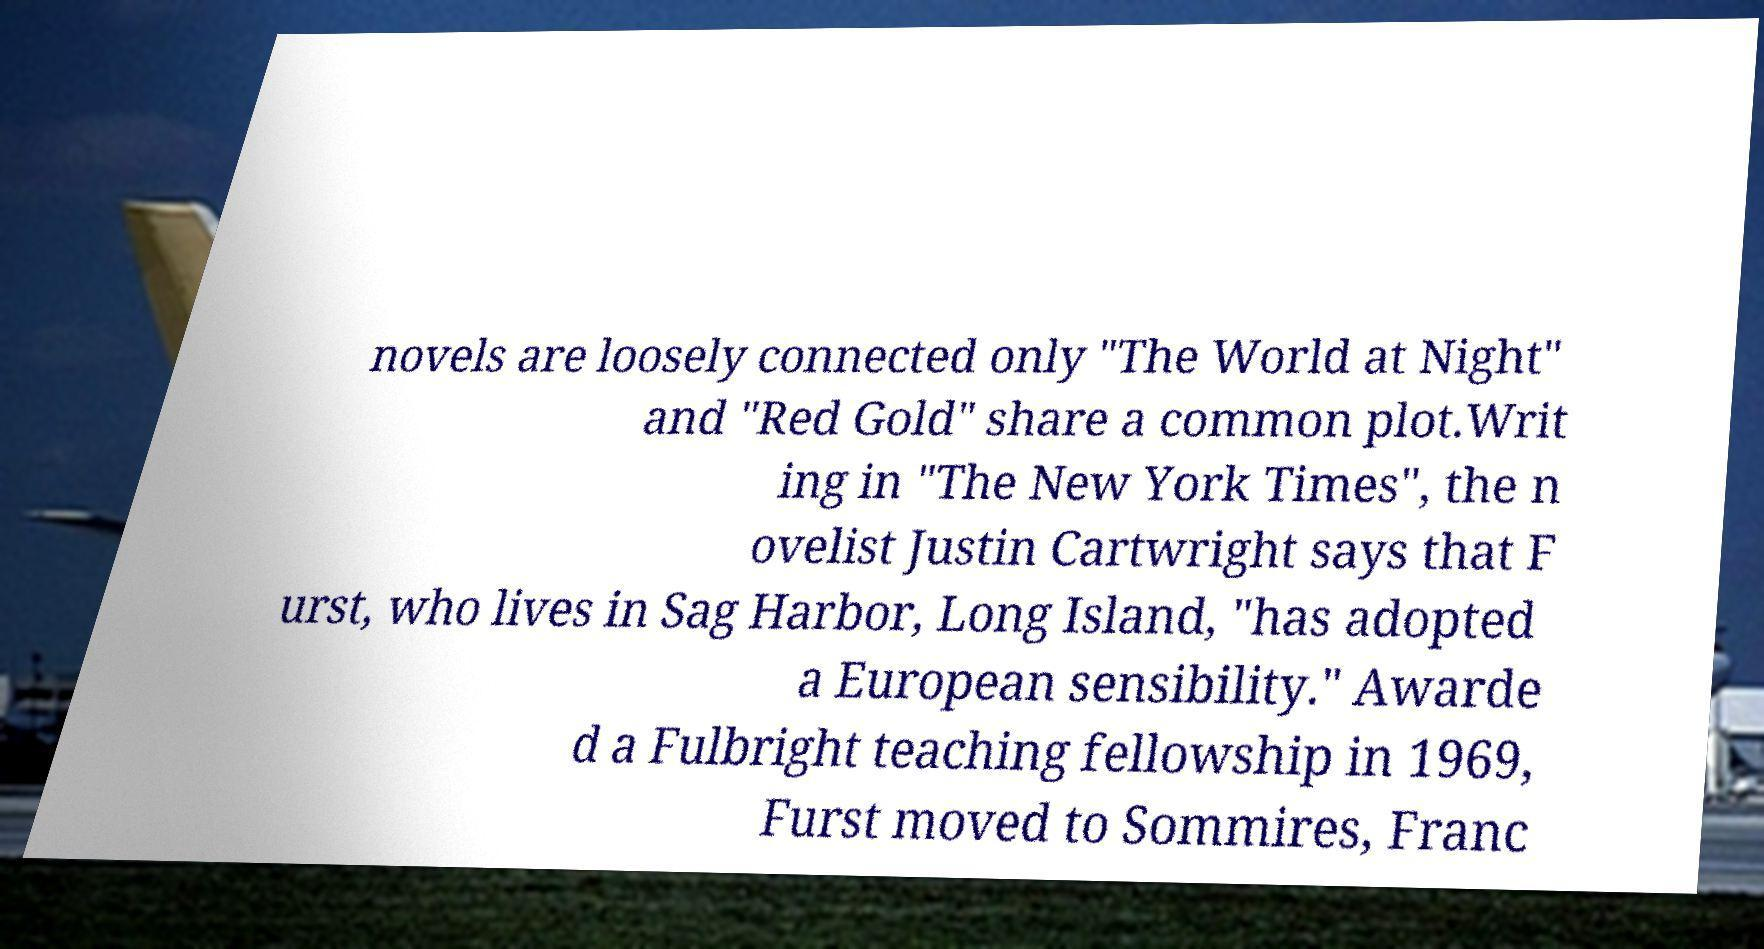What messages or text are displayed in this image? I need them in a readable, typed format. novels are loosely connected only "The World at Night" and "Red Gold" share a common plot.Writ ing in "The New York Times", the n ovelist Justin Cartwright says that F urst, who lives in Sag Harbor, Long Island, "has adopted a European sensibility." Awarde d a Fulbright teaching fellowship in 1969, Furst moved to Sommires, Franc 